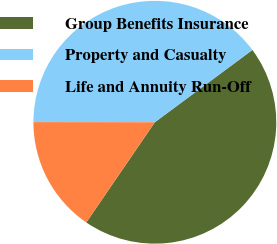Convert chart. <chart><loc_0><loc_0><loc_500><loc_500><pie_chart><fcel>Group Benefits Insurance<fcel>Property and Casualty<fcel>Life and Annuity Run-Off<nl><fcel>44.7%<fcel>39.83%<fcel>15.47%<nl></chart> 